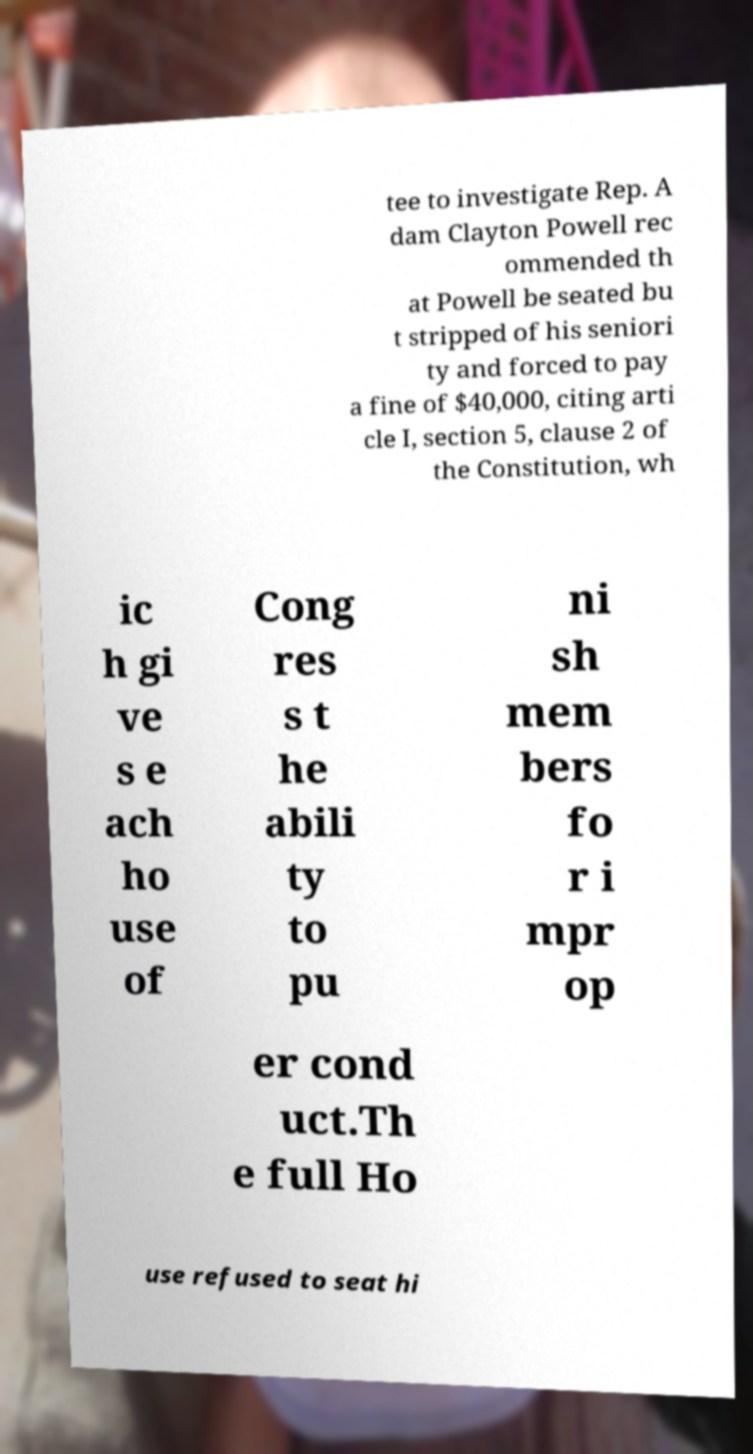What messages or text are displayed in this image? I need them in a readable, typed format. tee to investigate Rep. A dam Clayton Powell rec ommended th at Powell be seated bu t stripped of his seniori ty and forced to pay a fine of $40,000, citing arti cle I, section 5, clause 2 of the Constitution, wh ic h gi ve s e ach ho use of Cong res s t he abili ty to pu ni sh mem bers fo r i mpr op er cond uct.Th e full Ho use refused to seat hi 